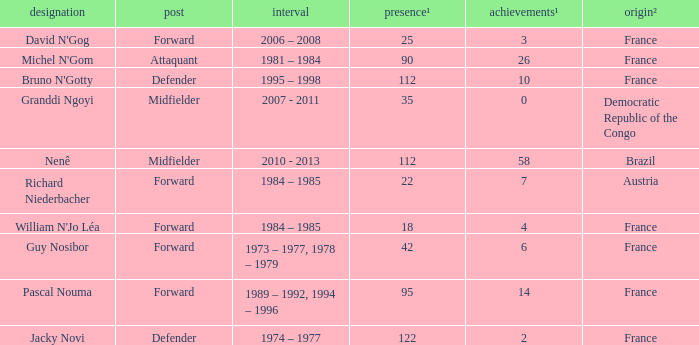List the player that scored 4 times. William N'Jo Léa. 